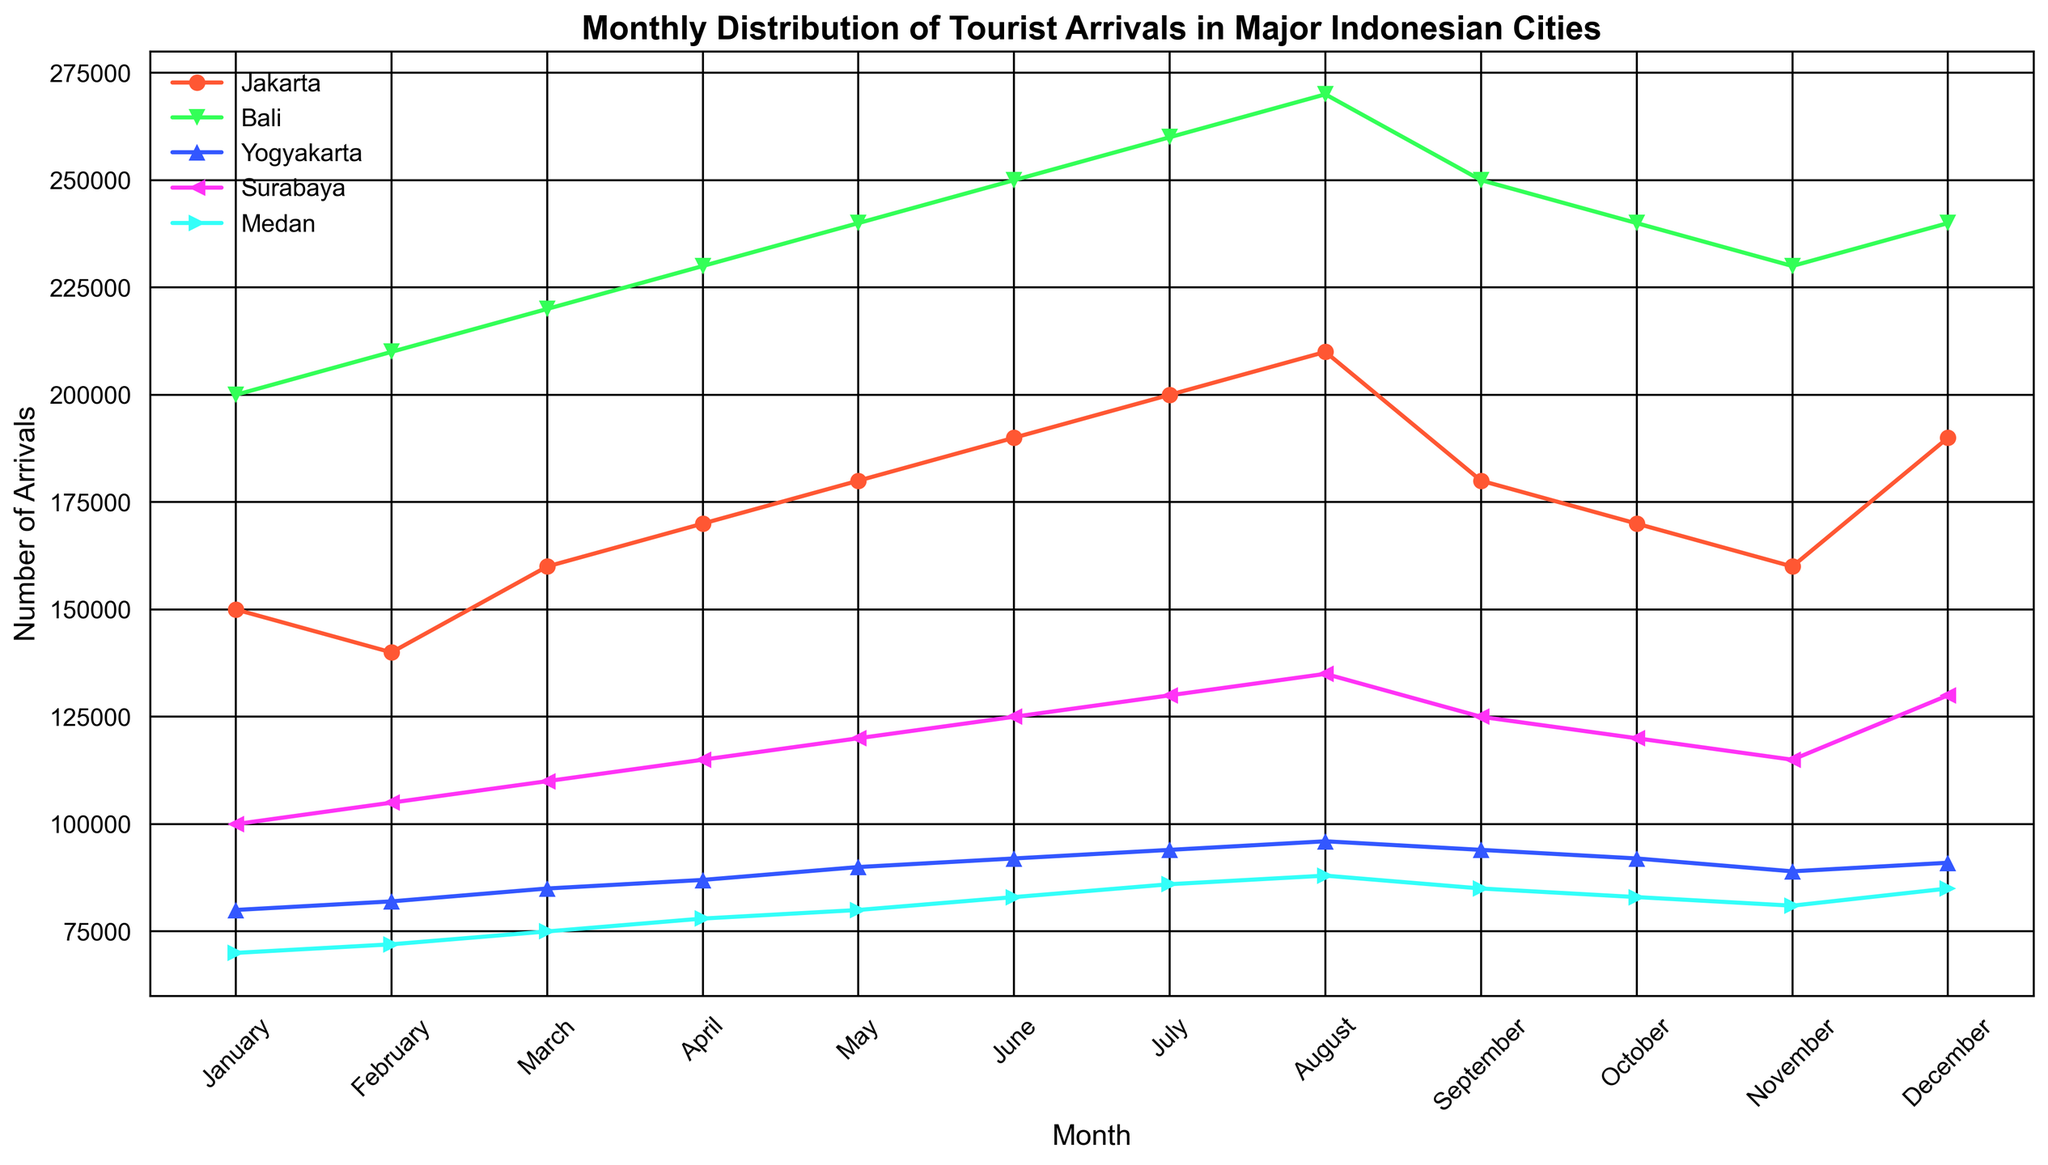Which city had the highest number of tourist arrivals in August? To find the city with the highest tourist arrivals in August, look at the values for all the cities in the August column. Bali has the highest value at 270,000.
Answer: Bali What is the difference in tourist arrivals between January and July for Jakarta? Subtract the number of arrivals in January from the number of arrivals in July for Jakarta (200,000 - 150,000).
Answer: 50,000 Which months have equal tourist arrivals for any of the cities? By examining the graph, identify months where the data points are at the same level. For instance, Bali has the same number of tourist arrivals in October and December (240,000).
Answer: October and December for Bali Among the cities, which one had the most significant increase in tourist arrivals from February to March? Compare the rises in arrivals between February and March for each city from the graph: Jakarta increased by 20,000, Bali by 10,000, Yogyakarta by 3,000, Surabaya by 5,000, and Medan by 3,000. Jakarta had the largest increase.
Answer: Jakarta How does the trend of tourist arrivals in Yogyakarta compare visually to that in Surabaya throughout the year? Both cities show an increasing trend from January, peak around July and August, and then decrease towards the end of the year. Both have a relatively stable and consistent pattern.
Answer: Similar rising then falling trends What is the average number of tourist arrivals in Bali from June to September? Sum the number of arrivals in those months for Bali and divide by 4: (250,000 + 260,000 + 270,000 + 250,000) / 4 = 1,030,000 / 4
Answer: 257,500 Which city shows the least variation in tourist arrivals throughout the year? By comparing the range of the data points for fluctuation: Yogyakarta has the least variation since its values range from 80,000 to 96,000, a smaller range compared to other cities.
Answer: Yogyakarta What is the combined number of tourist arrivals in December for Jakarta and Medan? Add the values of tourist arrivals for Jakarta and Medan in December (190,000 + 85,000).
Answer: 275,000 In which month do Bali's tourist arrivals peak, and what is the value? Check Bali's tourist arrivals month by month and notice the peak in August with 270,000 stated clearly.
Answer: August, 270,000 